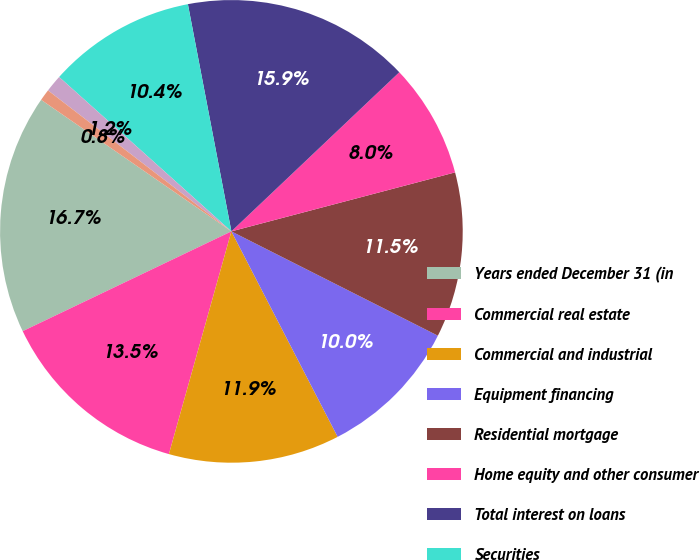<chart> <loc_0><loc_0><loc_500><loc_500><pie_chart><fcel>Years ended December 31 (in<fcel>Commercial real estate<fcel>Commercial and industrial<fcel>Equipment financing<fcel>Residential mortgage<fcel>Home equity and other consumer<fcel>Total interest on loans<fcel>Securities<fcel>Short-term investments<fcel>Loans held-for-sale<nl><fcel>16.73%<fcel>13.55%<fcel>11.95%<fcel>9.96%<fcel>11.55%<fcel>7.97%<fcel>15.94%<fcel>10.36%<fcel>1.2%<fcel>0.8%<nl></chart> 